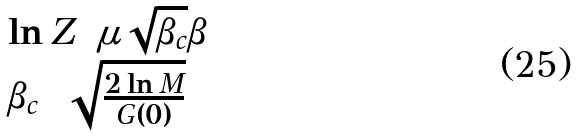Convert formula to latex. <formula><loc_0><loc_0><loc_500><loc_500>\begin{array} { l } \ln Z = { \mu \sqrt { \beta _ { c } } \beta } \\ \beta _ { c } = \sqrt { \frac { 2 \ln M } { G ( 0 ) } } \end{array}</formula> 